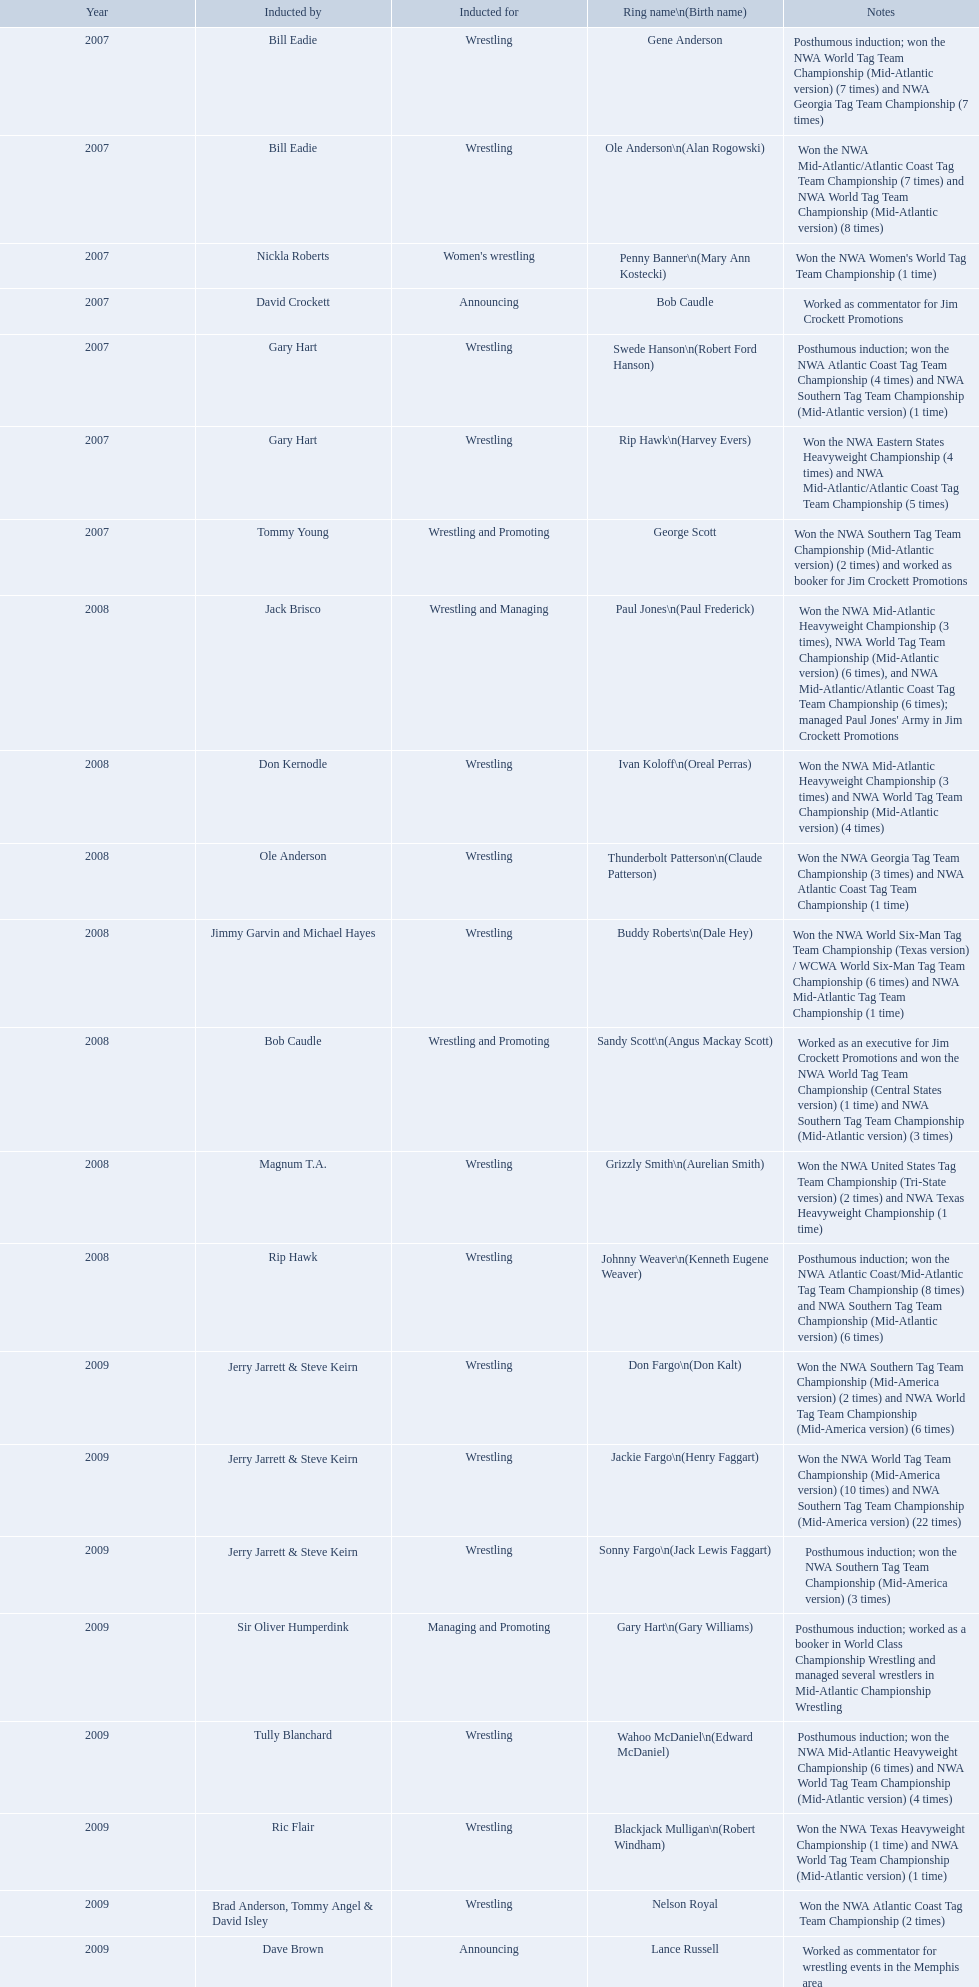What announcers were inducted? Bob Caudle, Lance Russell. What announcer was inducted in 2009? Lance Russell. What were all the wrestler's ring names? Gene Anderson, Ole Anderson\n(Alan Rogowski), Penny Banner\n(Mary Ann Kostecki), Bob Caudle, Swede Hanson\n(Robert Ford Hanson), Rip Hawk\n(Harvey Evers), George Scott, Paul Jones\n(Paul Frederick), Ivan Koloff\n(Oreal Perras), Thunderbolt Patterson\n(Claude Patterson), Buddy Roberts\n(Dale Hey), Sandy Scott\n(Angus Mackay Scott), Grizzly Smith\n(Aurelian Smith), Johnny Weaver\n(Kenneth Eugene Weaver), Don Fargo\n(Don Kalt), Jackie Fargo\n(Henry Faggart), Sonny Fargo\n(Jack Lewis Faggart), Gary Hart\n(Gary Williams), Wahoo McDaniel\n(Edward McDaniel), Blackjack Mulligan\n(Robert Windham), Nelson Royal, Lance Russell. Besides bob caudle, who was an announcer? Lance Russell. 